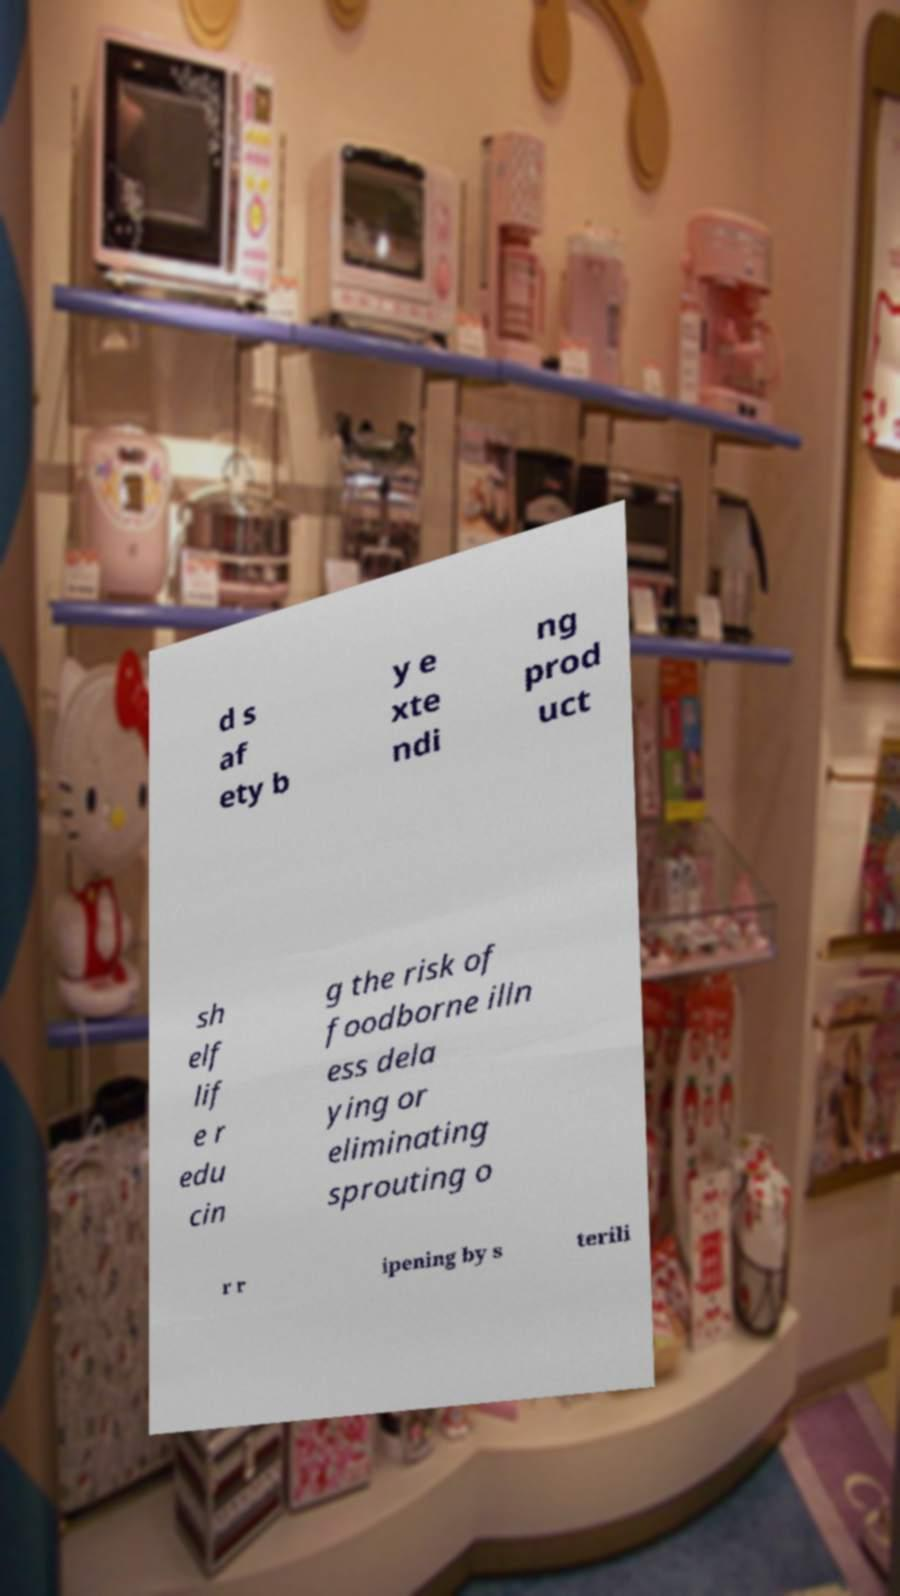Could you extract and type out the text from this image? d s af ety b y e xte ndi ng prod uct sh elf lif e r edu cin g the risk of foodborne illn ess dela ying or eliminating sprouting o r r ipening by s terili 